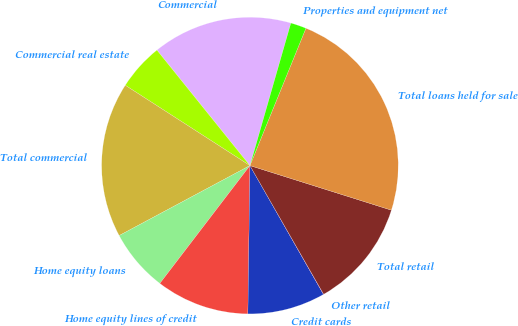<chart> <loc_0><loc_0><loc_500><loc_500><pie_chart><fcel>Commercial<fcel>Commercial real estate<fcel>Total commercial<fcel>Home equity loans<fcel>Home equity lines of credit<fcel>Credit cards<fcel>Other retail<fcel>Total retail<fcel>Total loans held for sale<fcel>Properties and equipment net<nl><fcel>15.24%<fcel>5.1%<fcel>16.93%<fcel>6.79%<fcel>10.17%<fcel>8.48%<fcel>0.02%<fcel>11.86%<fcel>23.7%<fcel>1.71%<nl></chart> 